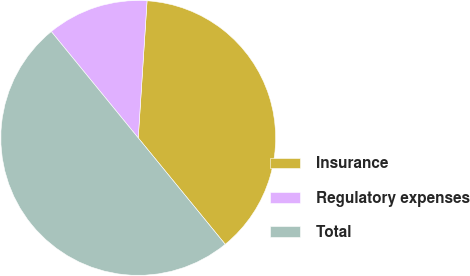Convert chart. <chart><loc_0><loc_0><loc_500><loc_500><pie_chart><fcel>Insurance<fcel>Regulatory expenses<fcel>Total<nl><fcel>38.07%<fcel>11.93%<fcel>50.0%<nl></chart> 